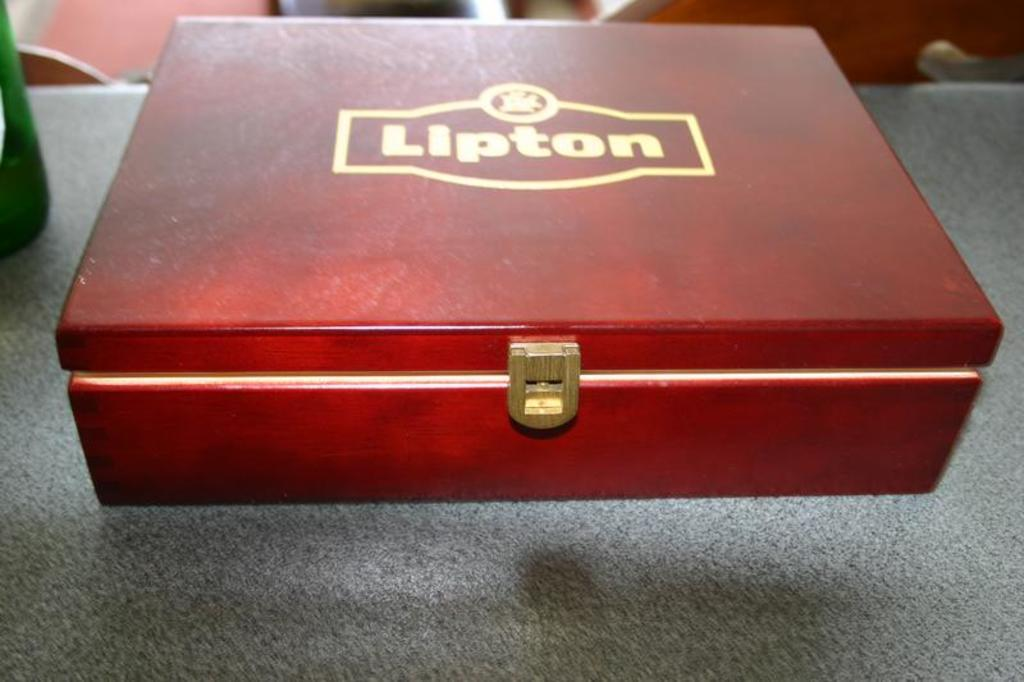<image>
Summarize the visual content of the image. a wooden box that is labeled 'lipton' on the top of it in gold 